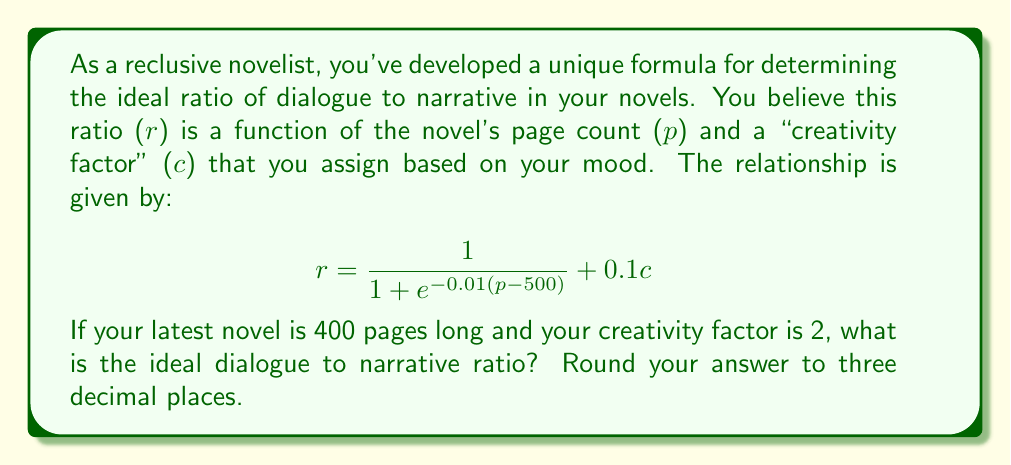Solve this math problem. To solve this problem, we need to follow these steps:

1. Identify the given values:
   $p = 400$ (page count)
   $c = 2$ (creativity factor)

2. Substitute these values into the given formula:

   $$ r = \frac{1}{1 + e^{-0.01(400-500)}} + 0.1(2) $$

3. Simplify the expression inside the exponential:
   
   $$ r = \frac{1}{1 + e^{-0.01(-100)}} + 0.2 $$
   
   $$ r = \frac{1}{1 + e^{1}} + 0.2 $$

4. Calculate the value of $e^1$:
   
   $e^1 \approx 2.71828$

5. Substitute this value:

   $$ r = \frac{1}{1 + 2.71828} + 0.2 $$

6. Calculate the fraction:

   $$ r = \frac{1}{3.71828} + 0.2 $$
   
   $$ r \approx 0.26893 + 0.2 $$

7. Sum the results:

   $$ r \approx 0.46893 $$

8. Round to three decimal places:

   $$ r \approx 0.469 $$

Thus, the ideal dialogue to narrative ratio for your 400-page novel with a creativity factor of 2 is approximately 0.469.
Answer: 0.469 